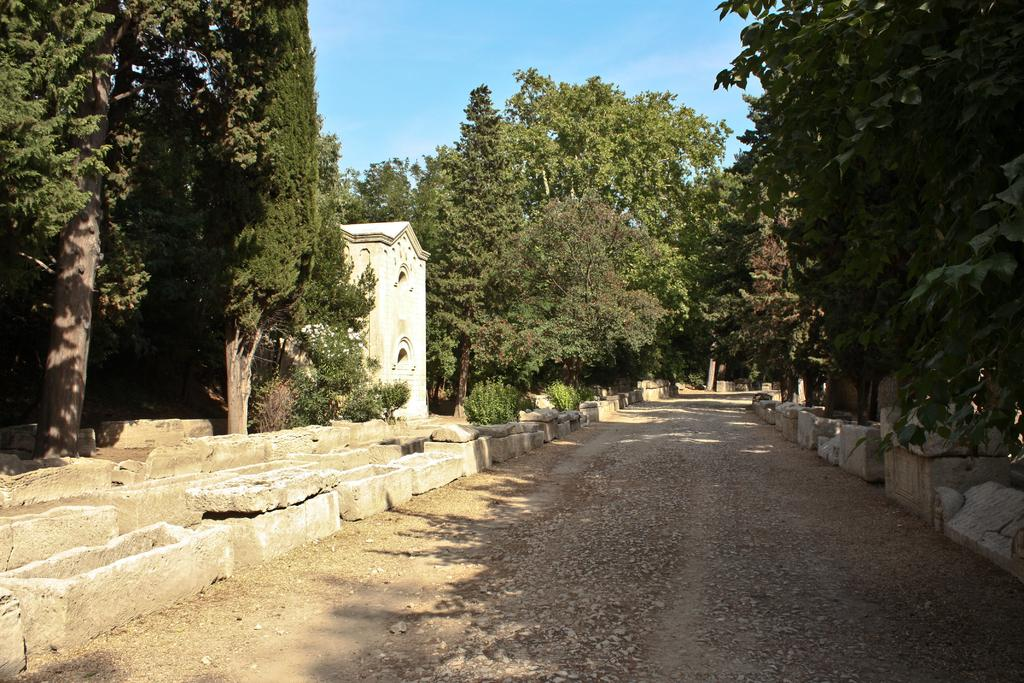What type of natural environment is depicted in the image? There are many trees in the image, suggesting a forest or wooded area. What man-made structure can be seen in the image? There is a house in the image. What type of pathway is present in the image? There is a road in the image. What is the condition of the sky in the image? The sky is clear and blue in the image. Where is the hammer being used in the image? There is no hammer present in the image. What type of animal can be seen near the gate in the image? There is no gate or rat present in the image. 